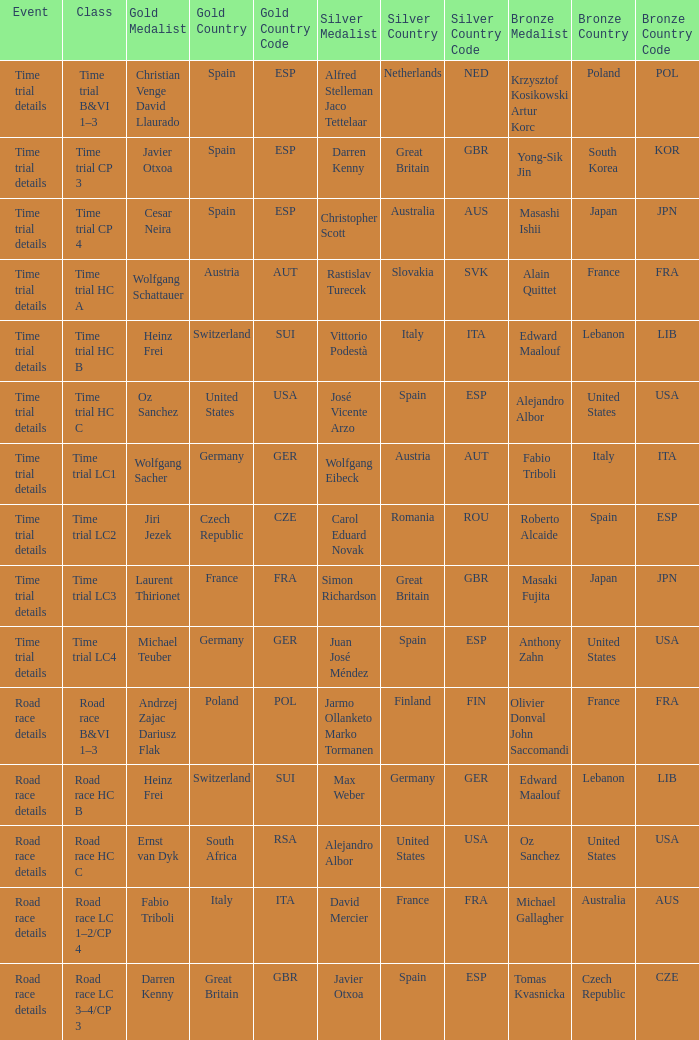Would you be able to parse every entry in this table? {'header': ['Event', 'Class', 'Gold Medalist', 'Gold Country', 'Gold Country Code', 'Silver Medalist', 'Silver Country', 'Silver Country Code', 'Bronze Medalist', 'Bronze Country', 'Bronze Country Code'], 'rows': [['Time trial details', 'Time trial B&VI 1–3', 'Christian Venge David Llaurado', 'Spain', 'ESP', 'Alfred Stelleman Jaco Tettelaar', 'Netherlands', 'NED', 'Krzysztof Kosikowski Artur Korc', 'Poland', 'POL'], ['Time trial details', 'Time trial CP 3', 'Javier Otxoa', 'Spain', 'ESP', 'Darren Kenny', 'Great Britain', 'GBR', 'Yong-Sik Jin', 'South Korea', 'KOR'], ['Time trial details', 'Time trial CP 4', 'Cesar Neira', 'Spain', 'ESP', 'Christopher Scott', 'Australia', 'AUS', 'Masashi Ishii', 'Japan', 'JPN'], ['Time trial details', 'Time trial HC A', 'Wolfgang Schattauer', 'Austria', 'AUT', 'Rastislav Turecek', 'Slovakia', 'SVK', 'Alain Quittet', 'France', 'FRA'], ['Time trial details', 'Time trial HC B', 'Heinz Frei', 'Switzerland', 'SUI', 'Vittorio Podestà', 'Italy', 'ITA', 'Edward Maalouf', 'Lebanon', 'LIB'], ['Time trial details', 'Time trial HC C', 'Oz Sanchez', 'United States', 'USA', 'José Vicente Arzo', 'Spain', 'ESP', 'Alejandro Albor', 'United States', 'USA'], ['Time trial details', 'Time trial LC1', 'Wolfgang Sacher', 'Germany', 'GER', 'Wolfgang Eibeck', 'Austria', 'AUT', 'Fabio Triboli', 'Italy', 'ITA'], ['Time trial details', 'Time trial LC2', 'Jiri Jezek', 'Czech Republic', 'CZE', 'Carol Eduard Novak', 'Romania', 'ROU', 'Roberto Alcaide', 'Spain', 'ESP'], ['Time trial details', 'Time trial LC3', 'Laurent Thirionet', 'France', 'FRA', 'Simon Richardson', 'Great Britain', 'GBR', 'Masaki Fujita', 'Japan', 'JPN'], ['Time trial details', 'Time trial LC4', 'Michael Teuber', 'Germany', 'GER', 'Juan José Méndez', 'Spain', 'ESP', 'Anthony Zahn', 'United States', 'USA'], ['Road race details', 'Road race B&VI 1–3', 'Andrzej Zajac Dariusz Flak', 'Poland', 'POL', 'Jarmo Ollanketo Marko Tormanen', 'Finland', 'FIN', 'Olivier Donval John Saccomandi', 'France', 'FRA'], ['Road race details', 'Road race HC B', 'Heinz Frei', 'Switzerland', 'SUI', 'Max Weber', 'Germany', 'GER', 'Edward Maalouf', 'Lebanon', 'LIB'], ['Road race details', 'Road race HC C', 'Ernst van Dyk', 'South Africa', 'RSA', 'Alejandro Albor', 'United States', 'USA', 'Oz Sanchez', 'United States', 'USA'], ['Road race details', 'Road race LC 1–2/CP 4', 'Fabio Triboli', 'Italy', 'ITA', 'David Mercier', 'France', 'FRA', 'Michael Gallagher', 'Australia', 'AUS'], ['Road race details', 'Road race LC 3–4/CP 3', 'Darren Kenny', 'Great Britain', 'GBR', 'Javier Otxoa', 'Spain', 'ESP', 'Tomas Kvasnicka', 'Czech Republic', 'CZE']]} Who received gold when silver is wolfgang eibeck austria (aut)? Wolfgang Sacher Germany (GER). 